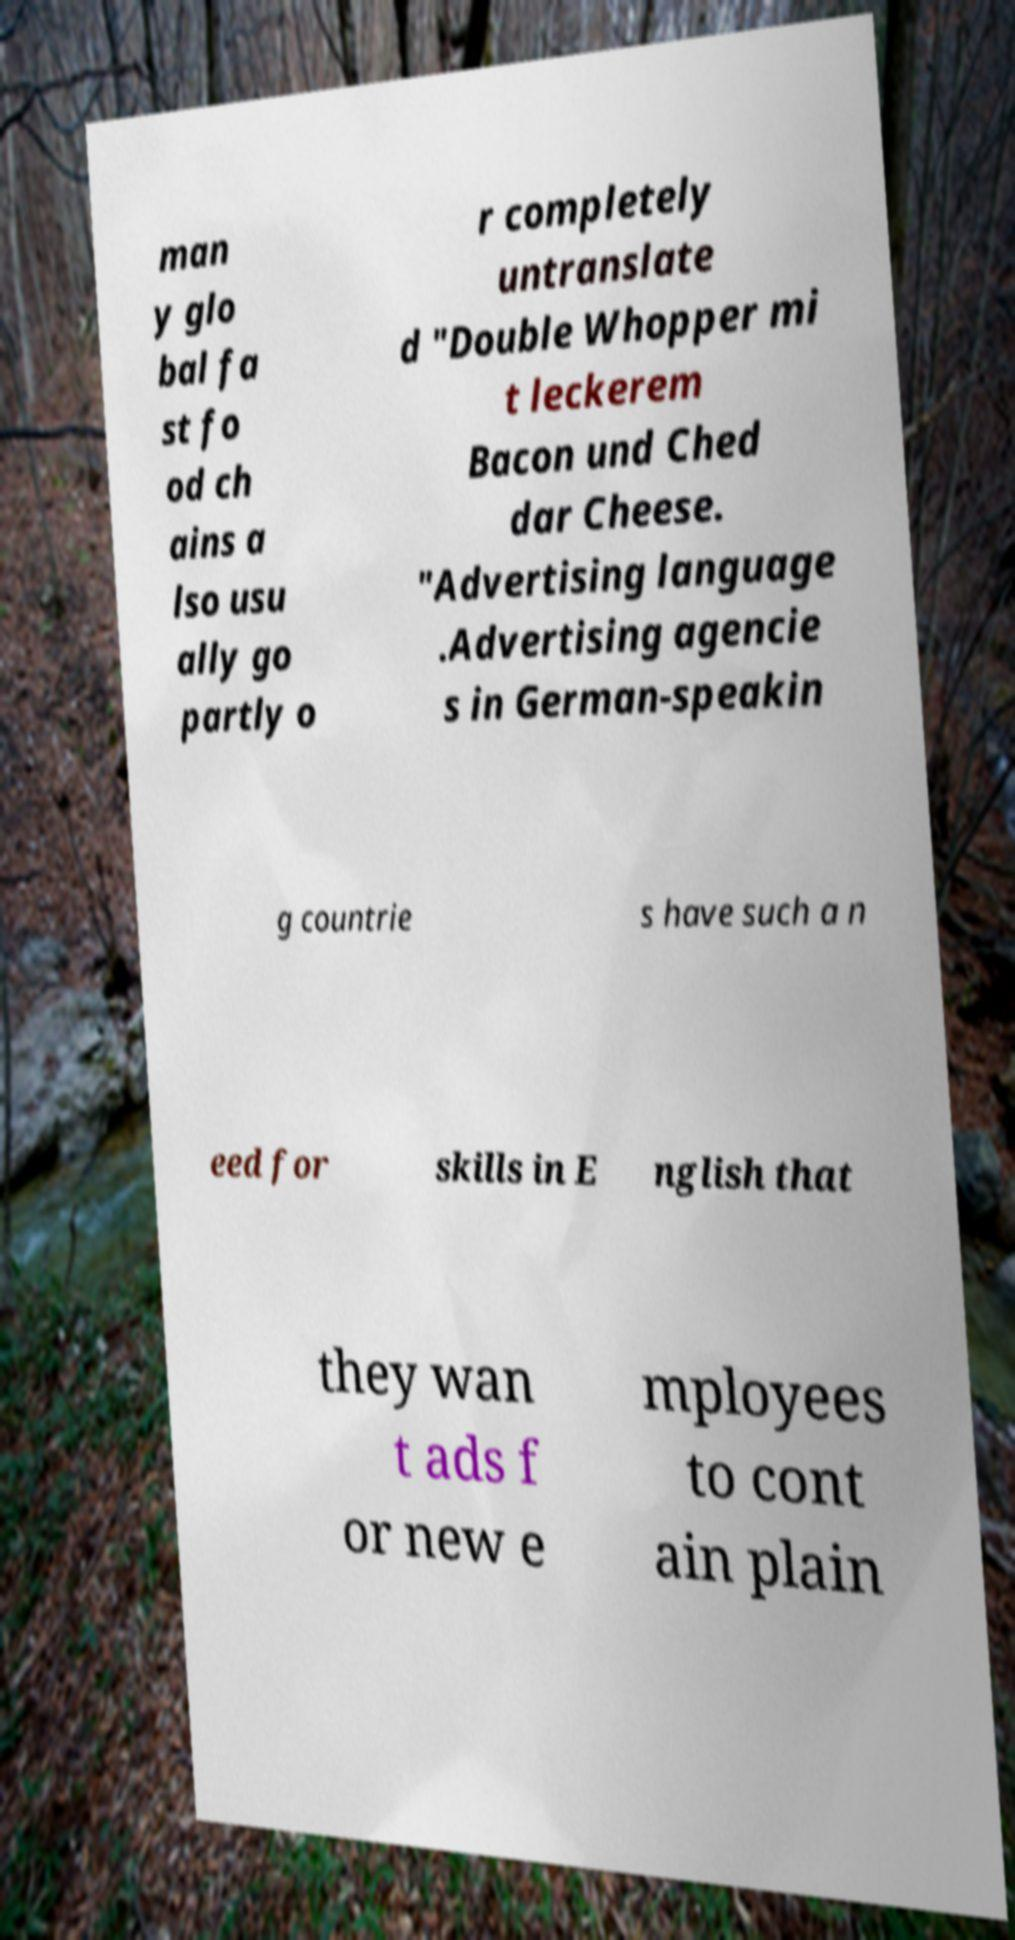What messages or text are displayed in this image? I need them in a readable, typed format. man y glo bal fa st fo od ch ains a lso usu ally go partly o r completely untranslate d "Double Whopper mi t leckerem Bacon und Ched dar Cheese. "Advertising language .Advertising agencie s in German-speakin g countrie s have such a n eed for skills in E nglish that they wan t ads f or new e mployees to cont ain plain 